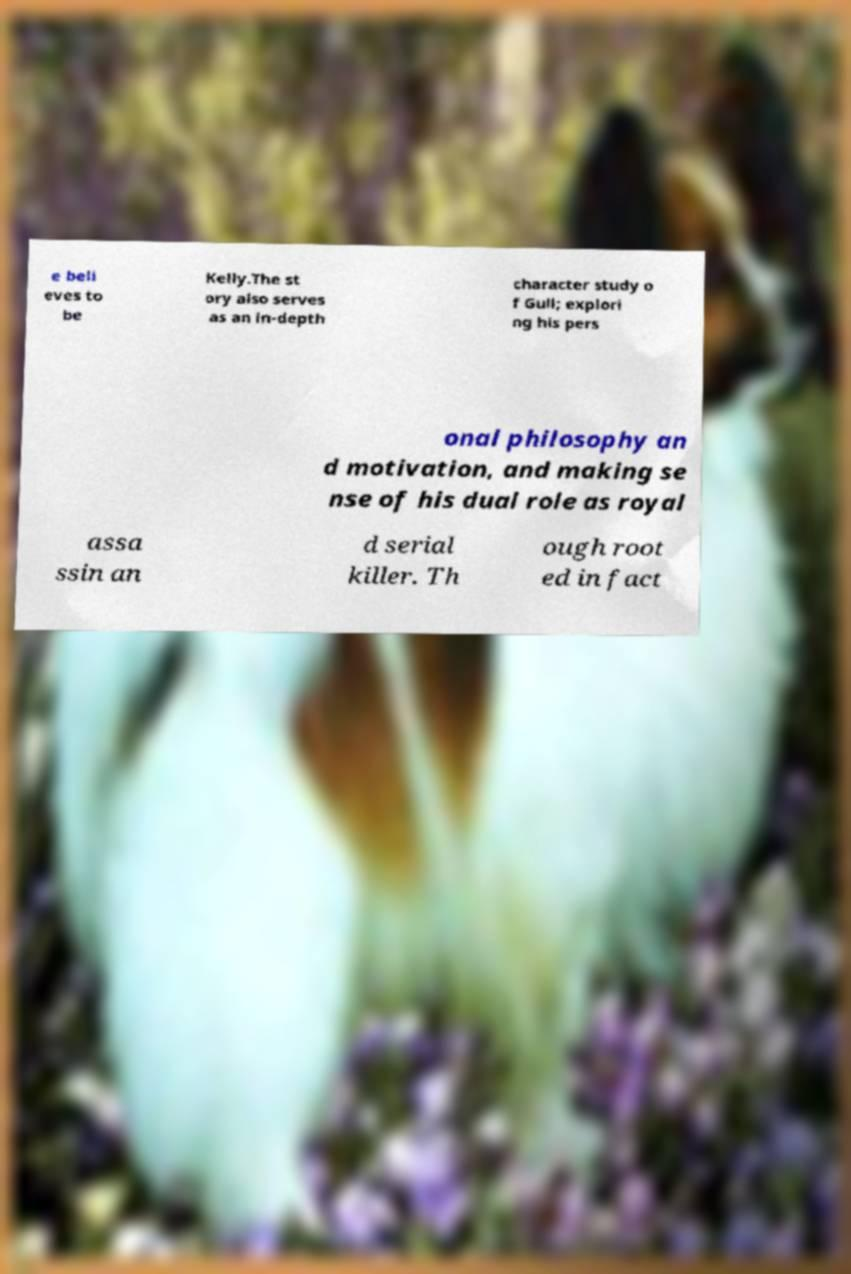Please identify and transcribe the text found in this image. e beli eves to be Kelly.The st ory also serves as an in-depth character study o f Gull; explori ng his pers onal philosophy an d motivation, and making se nse of his dual role as royal assa ssin an d serial killer. Th ough root ed in fact 